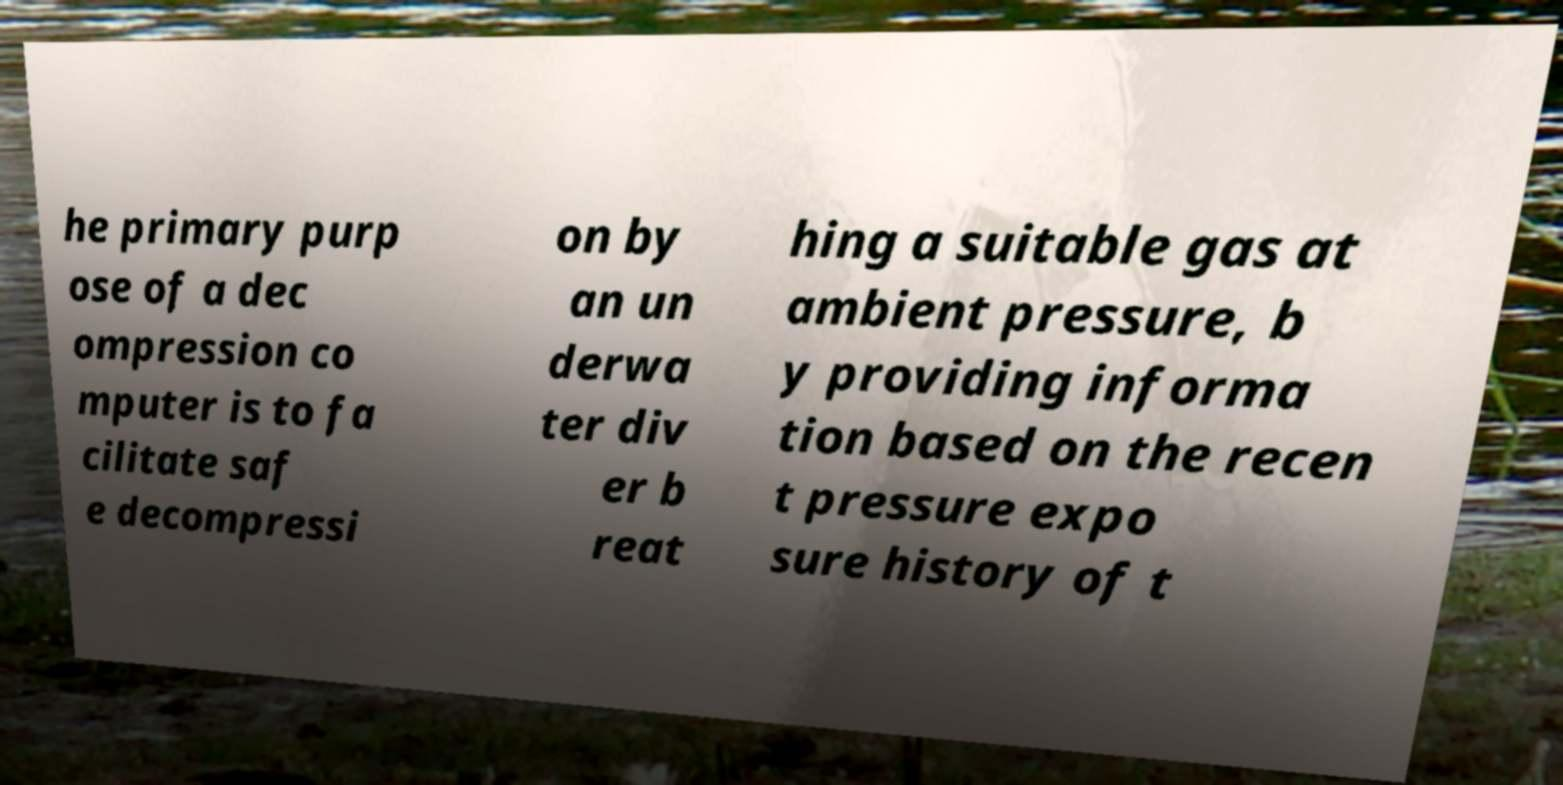There's text embedded in this image that I need extracted. Can you transcribe it verbatim? he primary purp ose of a dec ompression co mputer is to fa cilitate saf e decompressi on by an un derwa ter div er b reat hing a suitable gas at ambient pressure, b y providing informa tion based on the recen t pressure expo sure history of t 